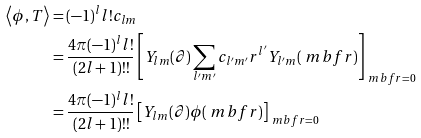Convert formula to latex. <formula><loc_0><loc_0><loc_500><loc_500>\left \langle \phi , T \right \rangle & = ( - 1 ) ^ { l } l ! c _ { l m } \\ & = \frac { 4 \pi ( - 1 ) ^ { l } l ! } { ( 2 l + 1 ) ! ! } \left [ Y _ { l m } ( \partial ) \sum _ { l ^ { \prime } m ^ { \prime } } c _ { l ^ { \prime } m ^ { \prime } } r ^ { l ^ { \prime } } Y _ { l ^ { \prime } m } ( \ m b f { r } ) \right ] _ { \ m b f { r } = 0 } \\ & = \frac { 4 \pi ( - 1 ) ^ { l } l ! } { ( 2 l + 1 ) ! ! } \left [ Y _ { l m } ( \partial ) \phi ( \ m b f { r } ) \right ] _ { \ m b f { r } = 0 }</formula> 